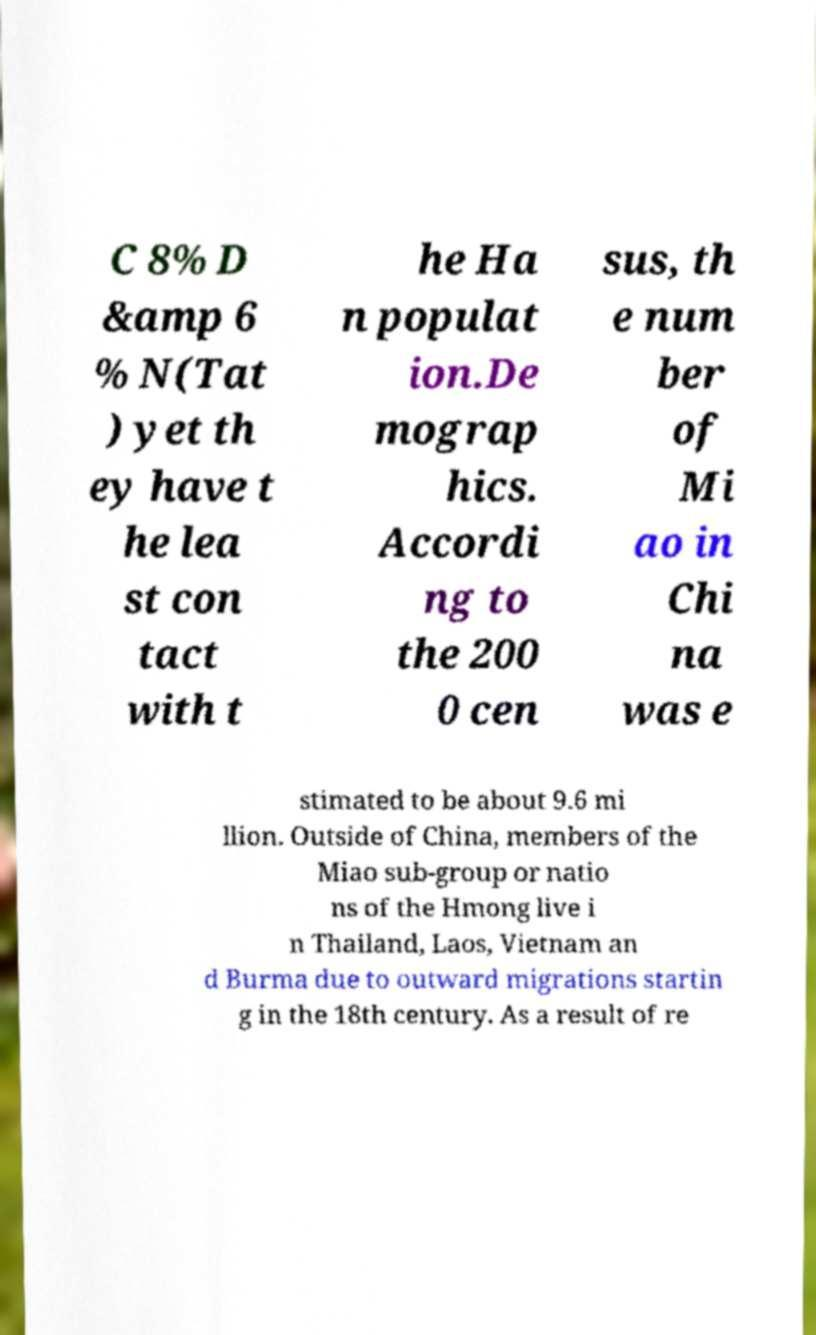Please identify and transcribe the text found in this image. C 8% D &amp 6 % N(Tat ) yet th ey have t he lea st con tact with t he Ha n populat ion.De mograp hics. Accordi ng to the 200 0 cen sus, th e num ber of Mi ao in Chi na was e stimated to be about 9.6 mi llion. Outside of China, members of the Miao sub-group or natio ns of the Hmong live i n Thailand, Laos, Vietnam an d Burma due to outward migrations startin g in the 18th century. As a result of re 